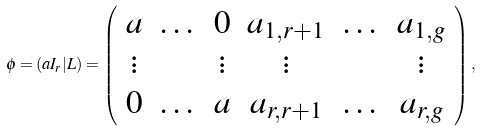Convert formula to latex. <formula><loc_0><loc_0><loc_500><loc_500>\phi = ( a I _ { r } | L ) = \left ( \begin{array} { c c c c c c } a & \dots & 0 & a _ { 1 , r + 1 } & \dots & a _ { 1 , g } \\ \vdots & & \vdots & \vdots & & \vdots \\ 0 & \dots & a & a _ { r , r + 1 } & \dots & a _ { r , g } \end{array} \right ) ,</formula> 